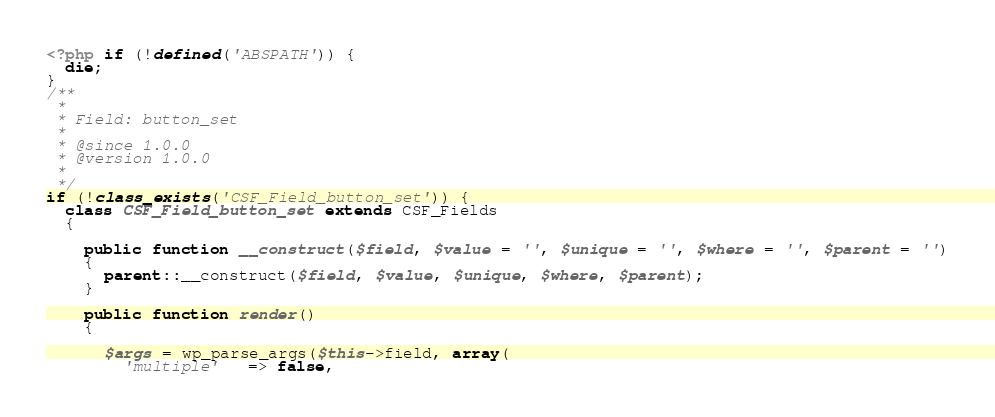<code> <loc_0><loc_0><loc_500><loc_500><_PHP_><?php if (!defined('ABSPATH')) {
  die;
}
/**
 *
 * Field: button_set
 *
 * @since 1.0.0
 * @version 1.0.0
 *
 */
if (!class_exists('CSF_Field_button_set')) {
  class CSF_Field_button_set extends CSF_Fields
  {

    public function __construct($field, $value = '', $unique = '', $where = '', $parent = '')
    {
      parent::__construct($field, $value, $unique, $where, $parent);
    }

    public function render()
    {

      $args = wp_parse_args($this->field, array(
        'multiple'   => false,</code> 